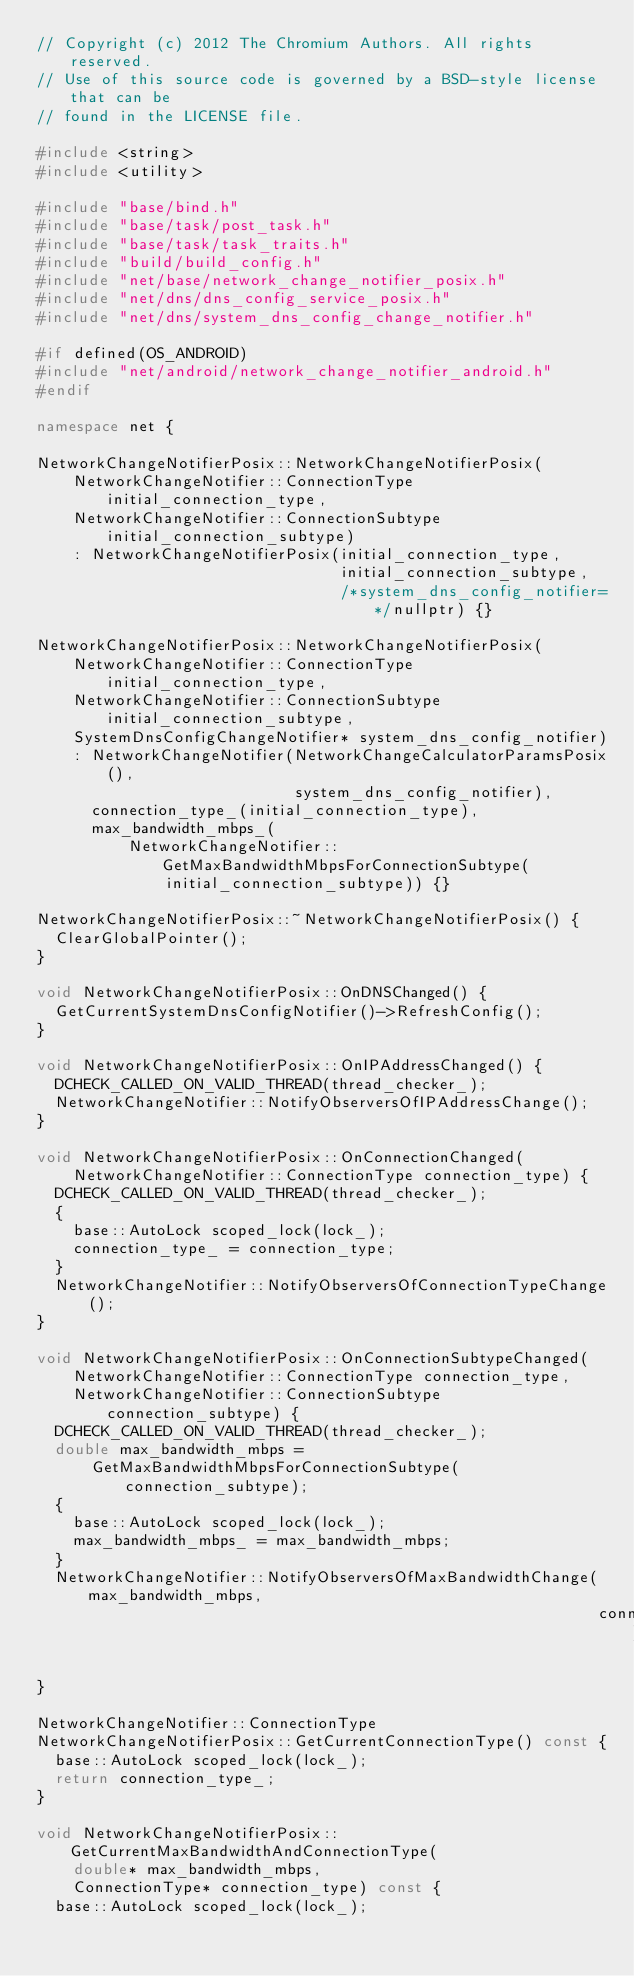<code> <loc_0><loc_0><loc_500><loc_500><_C++_>// Copyright (c) 2012 The Chromium Authors. All rights reserved.
// Use of this source code is governed by a BSD-style license that can be
// found in the LICENSE file.

#include <string>
#include <utility>

#include "base/bind.h"
#include "base/task/post_task.h"
#include "base/task/task_traits.h"
#include "build/build_config.h"
#include "net/base/network_change_notifier_posix.h"
#include "net/dns/dns_config_service_posix.h"
#include "net/dns/system_dns_config_change_notifier.h"

#if defined(OS_ANDROID)
#include "net/android/network_change_notifier_android.h"
#endif

namespace net {

NetworkChangeNotifierPosix::NetworkChangeNotifierPosix(
    NetworkChangeNotifier::ConnectionType initial_connection_type,
    NetworkChangeNotifier::ConnectionSubtype initial_connection_subtype)
    : NetworkChangeNotifierPosix(initial_connection_type,
                                 initial_connection_subtype,
                                 /*system_dns_config_notifier=*/nullptr) {}

NetworkChangeNotifierPosix::NetworkChangeNotifierPosix(
    NetworkChangeNotifier::ConnectionType initial_connection_type,
    NetworkChangeNotifier::ConnectionSubtype initial_connection_subtype,
    SystemDnsConfigChangeNotifier* system_dns_config_notifier)
    : NetworkChangeNotifier(NetworkChangeCalculatorParamsPosix(),
                            system_dns_config_notifier),
      connection_type_(initial_connection_type),
      max_bandwidth_mbps_(
          NetworkChangeNotifier::GetMaxBandwidthMbpsForConnectionSubtype(
              initial_connection_subtype)) {}

NetworkChangeNotifierPosix::~NetworkChangeNotifierPosix() {
  ClearGlobalPointer();
}

void NetworkChangeNotifierPosix::OnDNSChanged() {
  GetCurrentSystemDnsConfigNotifier()->RefreshConfig();
}

void NetworkChangeNotifierPosix::OnIPAddressChanged() {
  DCHECK_CALLED_ON_VALID_THREAD(thread_checker_);
  NetworkChangeNotifier::NotifyObserversOfIPAddressChange();
}

void NetworkChangeNotifierPosix::OnConnectionChanged(
    NetworkChangeNotifier::ConnectionType connection_type) {
  DCHECK_CALLED_ON_VALID_THREAD(thread_checker_);
  {
    base::AutoLock scoped_lock(lock_);
    connection_type_ = connection_type;
  }
  NetworkChangeNotifier::NotifyObserversOfConnectionTypeChange();
}

void NetworkChangeNotifierPosix::OnConnectionSubtypeChanged(
    NetworkChangeNotifier::ConnectionType connection_type,
    NetworkChangeNotifier::ConnectionSubtype connection_subtype) {
  DCHECK_CALLED_ON_VALID_THREAD(thread_checker_);
  double max_bandwidth_mbps =
      GetMaxBandwidthMbpsForConnectionSubtype(connection_subtype);
  {
    base::AutoLock scoped_lock(lock_);
    max_bandwidth_mbps_ = max_bandwidth_mbps;
  }
  NetworkChangeNotifier::NotifyObserversOfMaxBandwidthChange(max_bandwidth_mbps,
                                                             connection_type);
}

NetworkChangeNotifier::ConnectionType
NetworkChangeNotifierPosix::GetCurrentConnectionType() const {
  base::AutoLock scoped_lock(lock_);
  return connection_type_;
}

void NetworkChangeNotifierPosix::GetCurrentMaxBandwidthAndConnectionType(
    double* max_bandwidth_mbps,
    ConnectionType* connection_type) const {
  base::AutoLock scoped_lock(lock_);</code> 